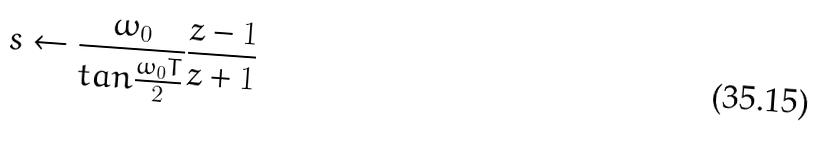Convert formula to latex. <formula><loc_0><loc_0><loc_500><loc_500>s \leftarrow \frac { \omega _ { 0 } } { t a n \frac { \omega _ { 0 } T } { 2 } } \frac { z - 1 } { z + 1 }</formula> 